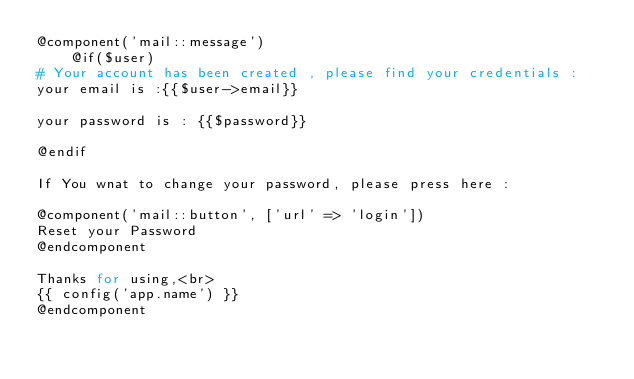<code> <loc_0><loc_0><loc_500><loc_500><_PHP_>@component('mail::message')
    @if($user)
# Your account has been created , please find your credentials :
your email is :{{$user->email}}

your password is : {{$password}}

@endif

If You wnat to change your password, please press here :

@component('mail::button', ['url' => 'login'])
Reset your Password
@endcomponent

Thanks for using,<br>
{{ config('app.name') }}
@endcomponent
</code> 